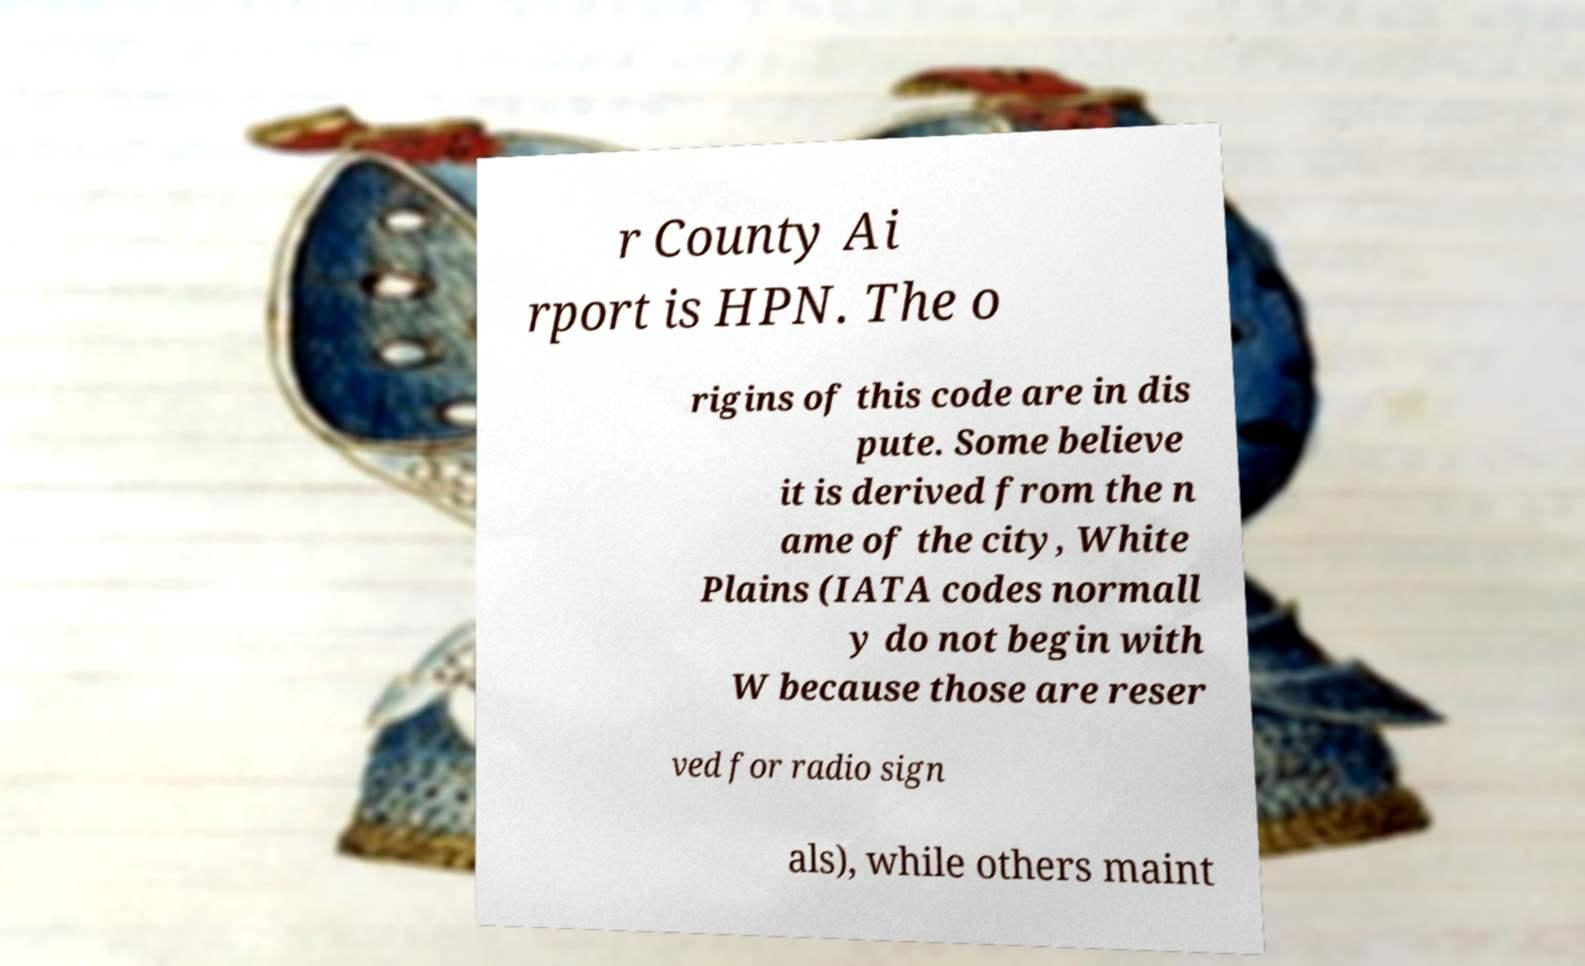Could you extract and type out the text from this image? r County Ai rport is HPN. The o rigins of this code are in dis pute. Some believe it is derived from the n ame of the city, White Plains (IATA codes normall y do not begin with W because those are reser ved for radio sign als), while others maint 